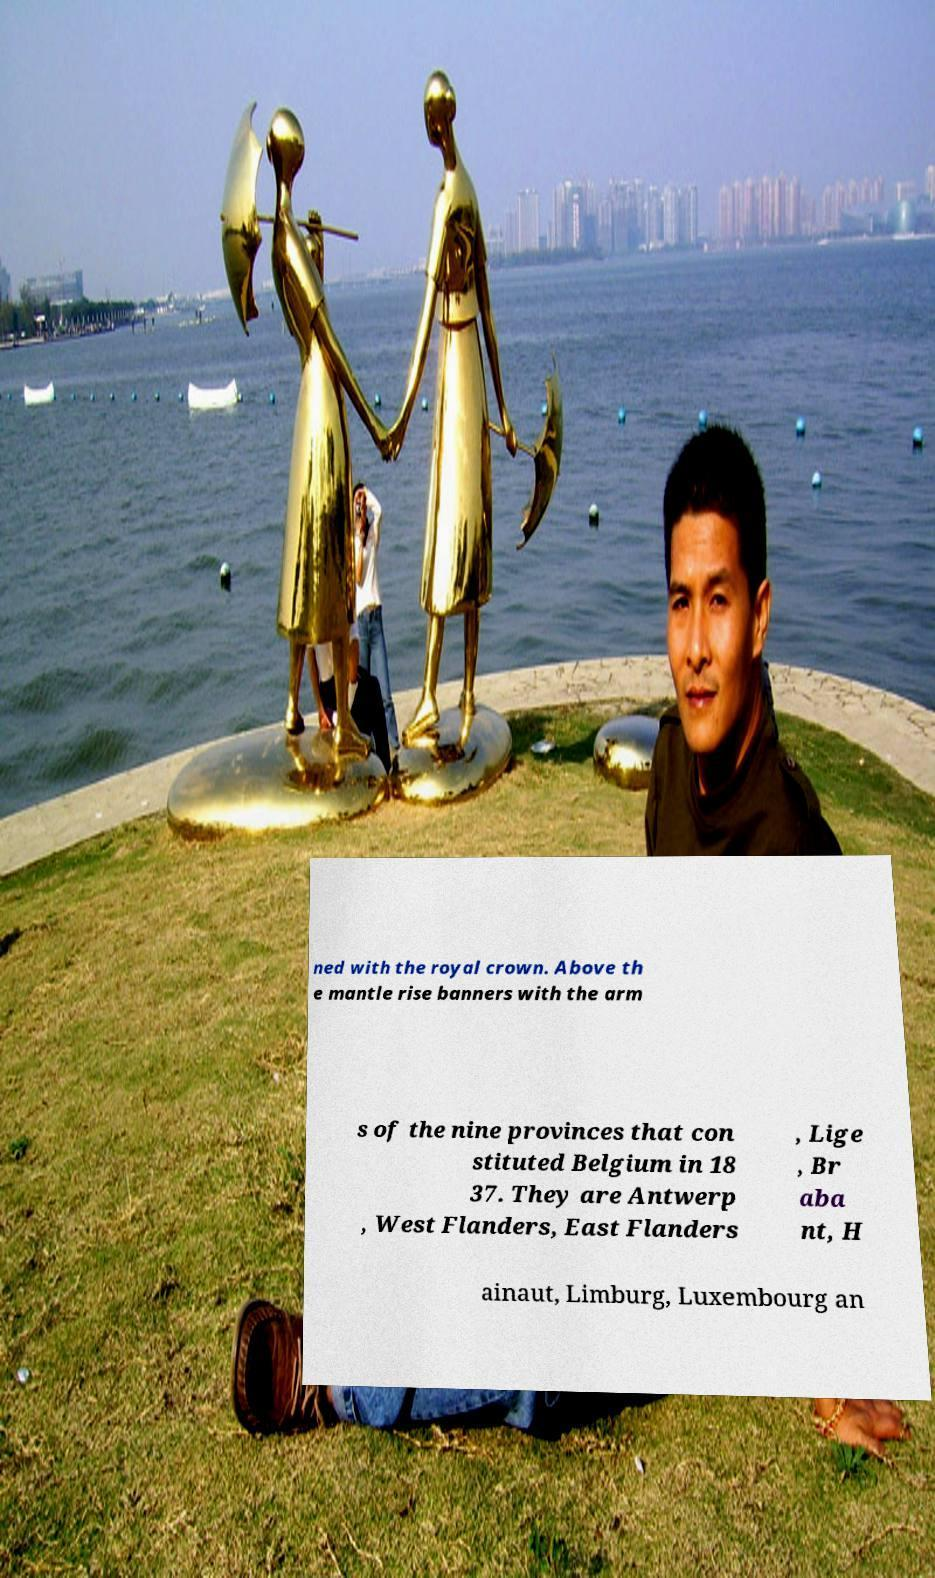What messages or text are displayed in this image? I need them in a readable, typed format. ned with the royal crown. Above th e mantle rise banners with the arm s of the nine provinces that con stituted Belgium in 18 37. They are Antwerp , West Flanders, East Flanders , Lige , Br aba nt, H ainaut, Limburg, Luxembourg an 